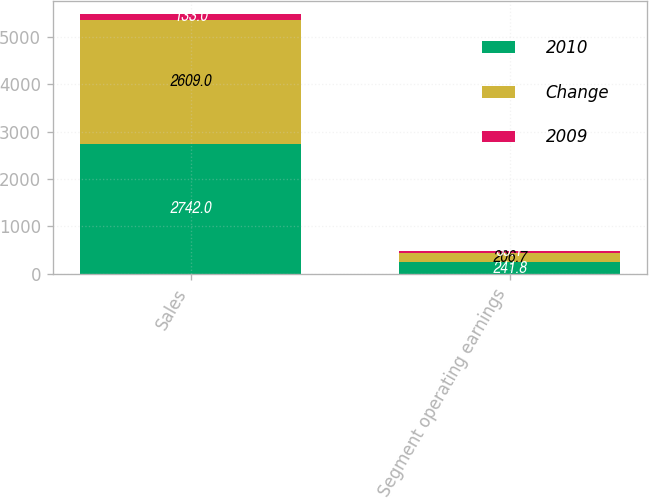Convert chart. <chart><loc_0><loc_0><loc_500><loc_500><stacked_bar_chart><ecel><fcel>Sales<fcel>Segment operating earnings<nl><fcel>2010<fcel>2742<fcel>241.8<nl><fcel>Change<fcel>2609<fcel>206.7<nl><fcel>2009<fcel>133<fcel>35.1<nl></chart> 